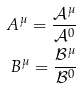<formula> <loc_0><loc_0><loc_500><loc_500>A ^ { \mu } = \frac { \mathcal { A } ^ { \mu } } { \mathcal { A } ^ { 0 } } \\ B ^ { \mu } = \frac { \mathcal { B } ^ { \mu } } { \mathcal { B } ^ { 0 } }</formula> 